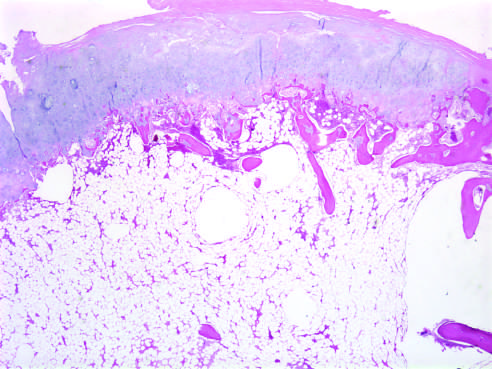what has the histologic appearance of disorganized growth plate-like cartilage?
Answer the question using a single word or phrase. The cartilage cap 